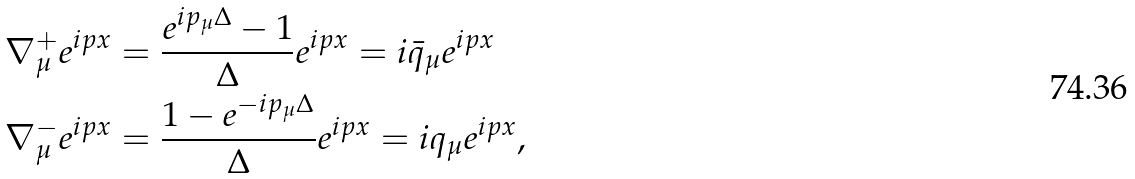Convert formula to latex. <formula><loc_0><loc_0><loc_500><loc_500>\nabla _ { \mu } ^ { + } e ^ { i p x } & = \frac { e ^ { i p _ { \mu } \Delta } - 1 } { \Delta } e ^ { i p x } = i \bar { q } _ { \mu } e ^ { i p x } \\ \nabla _ { \mu } ^ { - } e ^ { i p x } & = \frac { 1 - e ^ { - i p _ { \mu } \Delta } } { \Delta } e ^ { i p x } = i q _ { \mu } e ^ { i p x } ,</formula> 